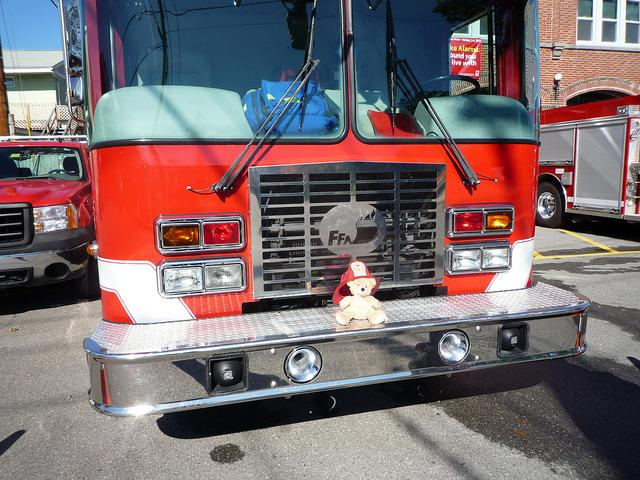How many types of fire engines are available?

Choices:
A) four
B) five
C) three
D) two four 